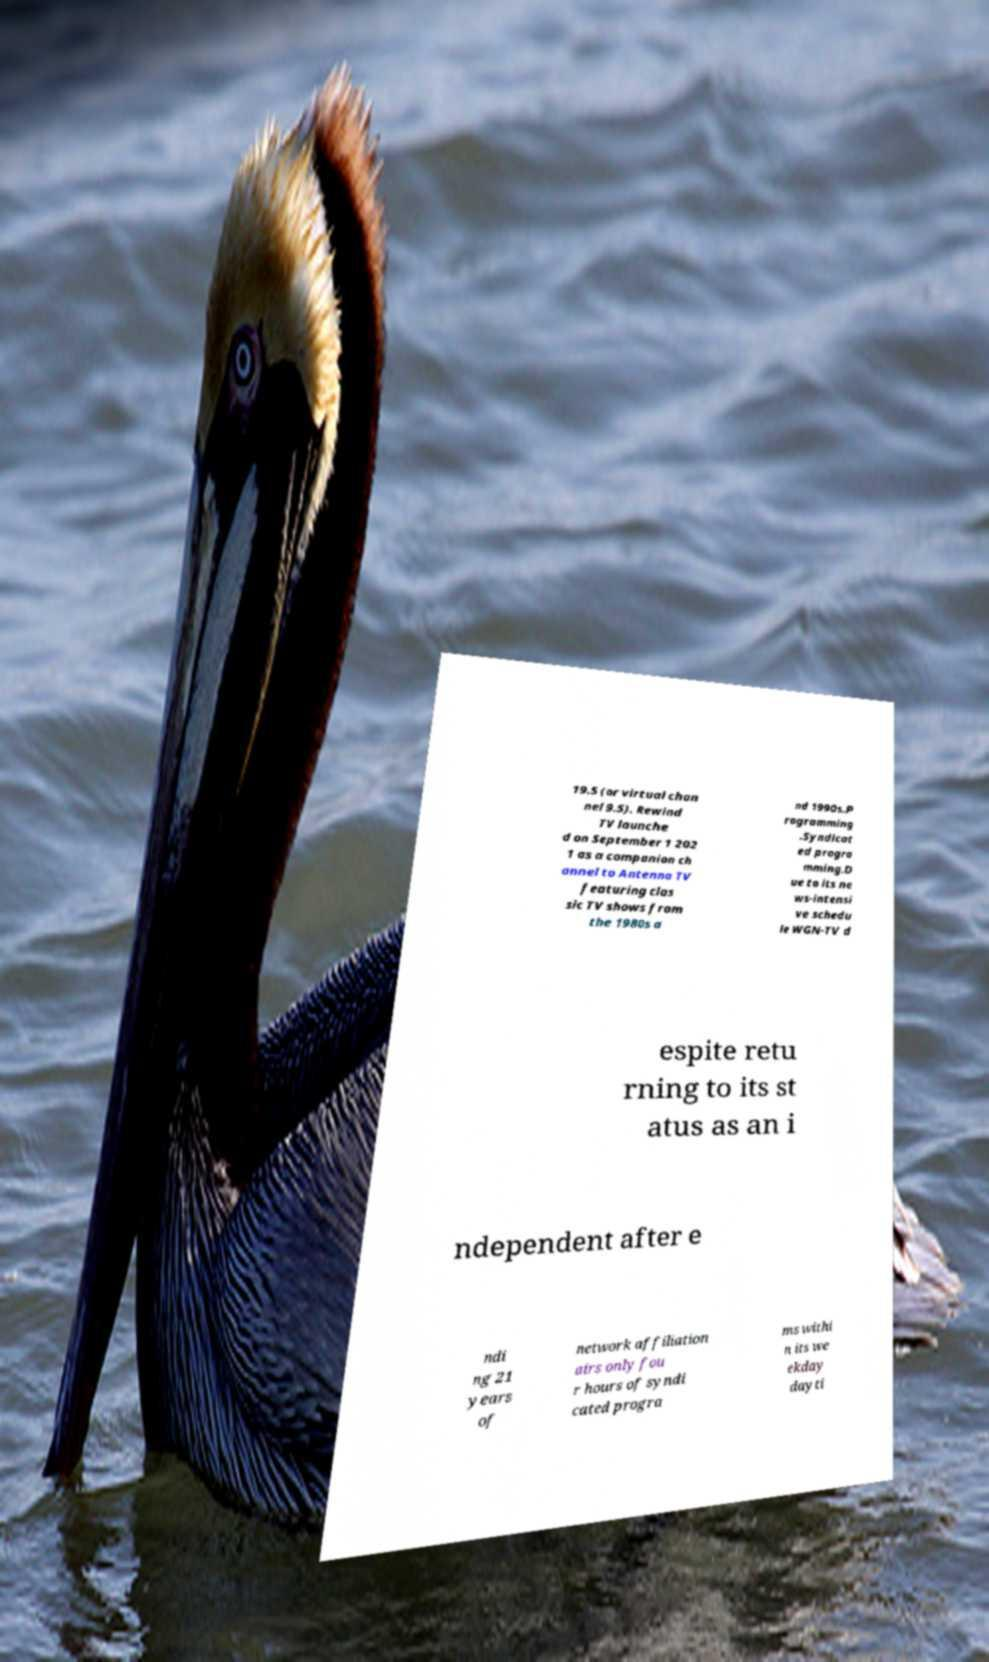For documentation purposes, I need the text within this image transcribed. Could you provide that? 19.5 (or virtual chan nel 9.5). Rewind TV launche d on September 1 202 1 as a companion ch annel to Antenna TV featuring clas sic TV shows from the 1980s a nd 1990s.P rogramming .Syndicat ed progra mming.D ue to its ne ws-intensi ve schedu le WGN-TV d espite retu rning to its st atus as an i ndependent after e ndi ng 21 years of network affiliation airs only fou r hours of syndi cated progra ms withi n its we ekday dayti 